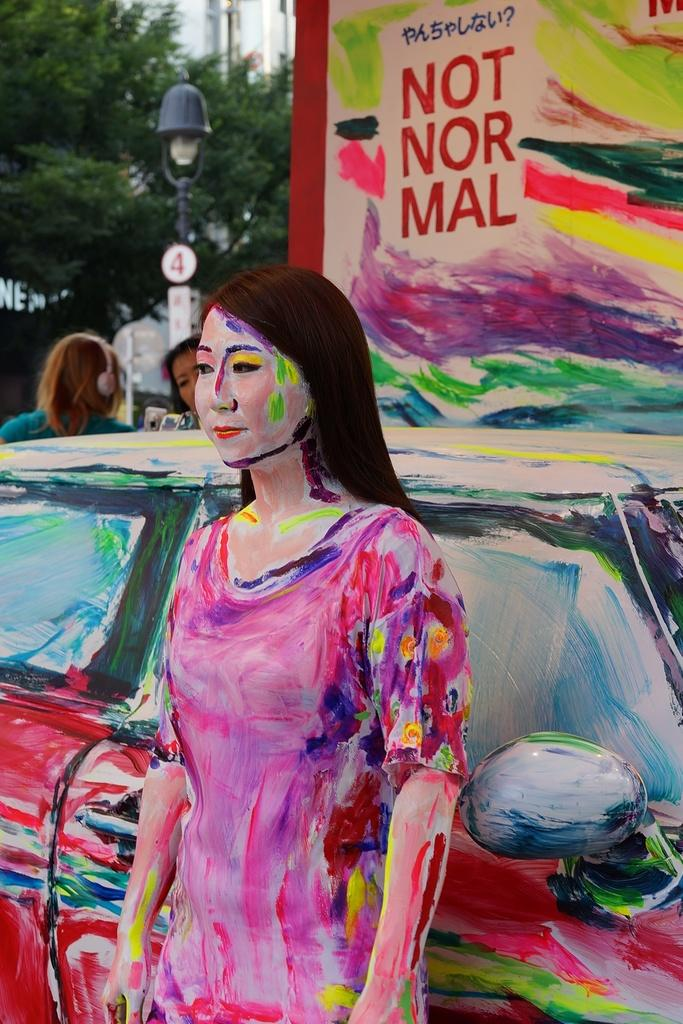What is the main subject in the image? There is a statue of a woman in the image. Can you describe any other objects or elements in the image? Yes, there is a car in the image. What type of plate is being sold at the market in the image? There is no market or plate present in the image; it features a statue of a woman and a car. How many straws are visible in the image? There are no straws present in the image. 